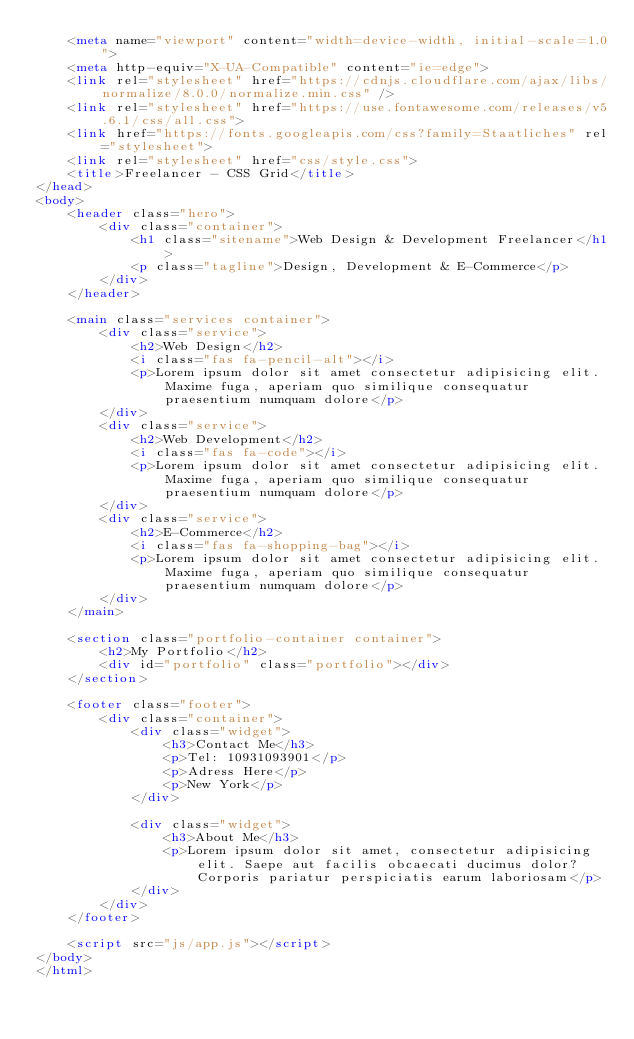<code> <loc_0><loc_0><loc_500><loc_500><_HTML_>    <meta name="viewport" content="width=device-width, initial-scale=1.0">
    <meta http-equiv="X-UA-Compatible" content="ie=edge">
    <link rel="stylesheet" href="https://cdnjs.cloudflare.com/ajax/libs/normalize/8.0.0/normalize.min.css" />
    <link rel="stylesheet" href="https://use.fontawesome.com/releases/v5.6.1/css/all.css">
    <link href="https://fonts.googleapis.com/css?family=Staatliches" rel="stylesheet">
    <link rel="stylesheet" href="css/style.css">
    <title>Freelancer - CSS Grid</title>
</head>
<body>
    <header class="hero">
        <div class="container">
            <h1 class="sitename">Web Design & Development Freelancer</h1>
            <p class="tagline">Design, Development & E-Commerce</p>
        </div>
    </header>

    <main class="services container">
        <div class="service">
            <h2>Web Design</h2>
            <i class="fas fa-pencil-alt"></i>
            <p>Lorem ipsum dolor sit amet consectetur adipisicing elit. Maxime fuga, aperiam quo similique consequatur praesentium numquam dolore</p>
        </div>
        <div class="service">
            <h2>Web Development</h2>
            <i class="fas fa-code"></i>
            <p>Lorem ipsum dolor sit amet consectetur adipisicing elit. Maxime fuga, aperiam quo similique consequatur praesentium numquam dolore</p>
        </div>
        <div class="service">
            <h2>E-Commerce</h2>
            <i class="fas fa-shopping-bag"></i>
            <p>Lorem ipsum dolor sit amet consectetur adipisicing elit. Maxime fuga, aperiam quo similique consequatur praesentium numquam dolore</p>
        </div>
    </main>

    <section class="portfolio-container container">
        <h2>My Portfolio</h2>
        <div id="portfolio" class="portfolio"></div>
    </section>

    <footer class="footer">
        <div class="container">
            <div class="widget">
                <h3>Contact Me</h3>
                <p>Tel: 10931093901</p>
                <p>Adress Here</p>
                <p>New York</p>
            </div>

            <div class="widget">
                <h3>About Me</h3>
                <p>Lorem ipsum dolor sit amet, consectetur adipisicing elit. Saepe aut facilis obcaecati ducimus dolor? Corporis pariatur perspiciatis earum laboriosam</p>
            </div>
        </div>
    </footer>

    <script src="js/app.js"></script>
</body>
</html></code> 